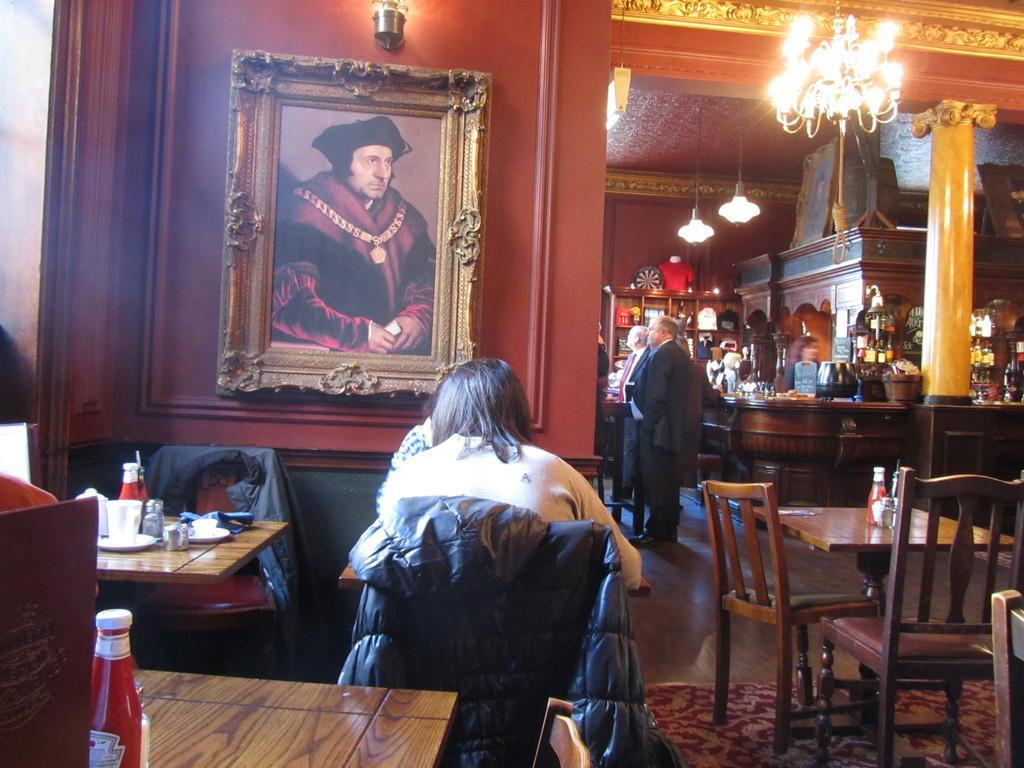Describe this image in one or two sentences. There is a group of people. In center we have a person. She is sitting on a chair. We can see the background is there is photo frame,lights ,table. 